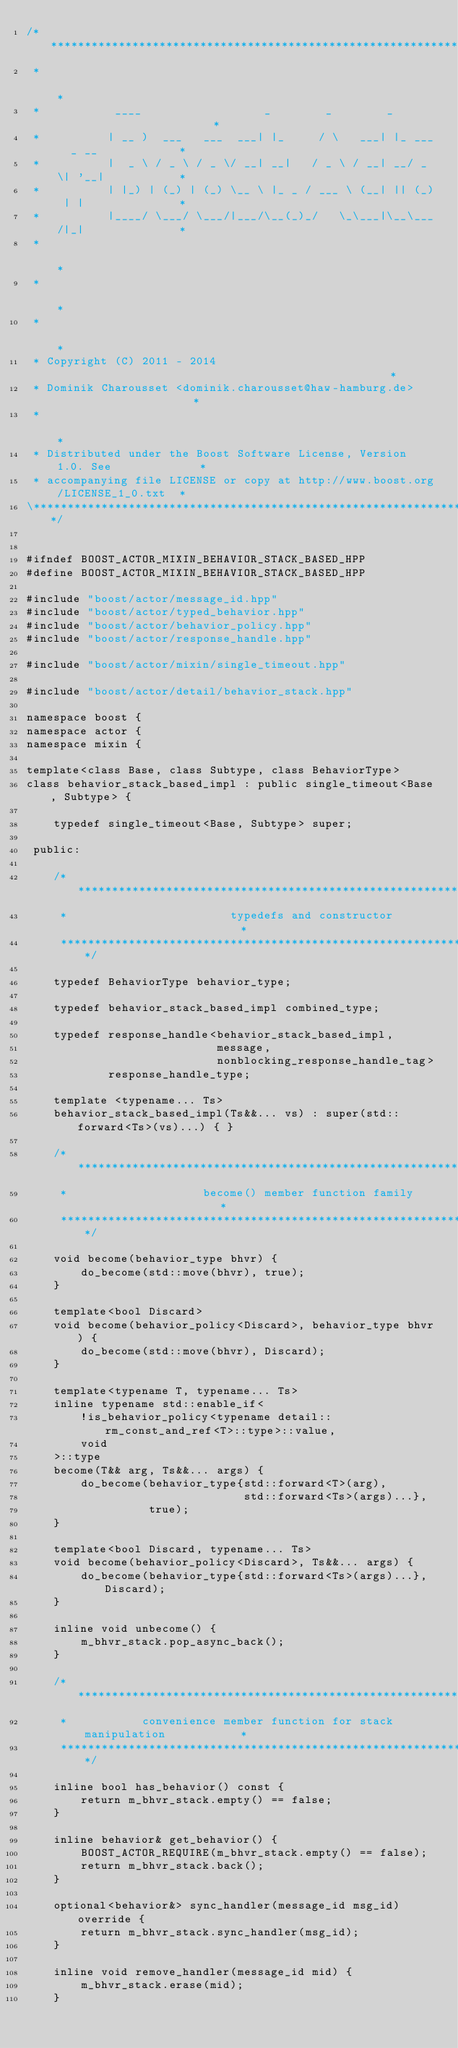Convert code to text. <code><loc_0><loc_0><loc_500><loc_500><_C++_>/******************************************************************************\
 *                                                                            *
 *           ____                  _        _        _                        *
 *          | __ )  ___   ___  ___| |_     / \   ___| |_ ___  _ __            *
 *          |  _ \ / _ \ / _ \/ __| __|   / _ \ / __| __/ _ \| '__|           *
 *          | |_) | (_) | (_) \__ \ |_ _ / ___ \ (__| || (_) | |              *
 *          |____/ \___/ \___/|___/\__(_)_/   \_\___|\__\___/|_|              *
 *                                                                            *
 *                                                                            *
 *                                                                            *
 * Copyright (C) 2011 - 2014                                                  *
 * Dominik Charousset <dominik.charousset@haw-hamburg.de>                     *
 *                                                                            *
 * Distributed under the Boost Software License, Version 1.0. See             *
 * accompanying file LICENSE or copy at http://www.boost.org/LICENSE_1_0.txt  *
\******************************************************************************/


#ifndef BOOST_ACTOR_MIXIN_BEHAVIOR_STACK_BASED_HPP
#define BOOST_ACTOR_MIXIN_BEHAVIOR_STACK_BASED_HPP

#include "boost/actor/message_id.hpp"
#include "boost/actor/typed_behavior.hpp"
#include "boost/actor/behavior_policy.hpp"
#include "boost/actor/response_handle.hpp"

#include "boost/actor/mixin/single_timeout.hpp"

#include "boost/actor/detail/behavior_stack.hpp"

namespace boost {
namespace actor {
namespace mixin {

template<class Base, class Subtype, class BehaviorType>
class behavior_stack_based_impl : public single_timeout<Base, Subtype> {

    typedef single_timeout<Base, Subtype> super;

 public:

    /**************************************************************************
     *                        typedefs and constructor                        *
     **************************************************************************/

    typedef BehaviorType behavior_type;

    typedef behavior_stack_based_impl combined_type;

    typedef response_handle<behavior_stack_based_impl,
                            message,
                            nonblocking_response_handle_tag>
            response_handle_type;

    template <typename... Ts>
    behavior_stack_based_impl(Ts&&... vs) : super(std::forward<Ts>(vs)...) { }

    /**************************************************************************
     *                    become() member function family                     *
     **************************************************************************/

    void become(behavior_type bhvr) {
        do_become(std::move(bhvr), true);
    }

    template<bool Discard>
    void become(behavior_policy<Discard>, behavior_type bhvr) {
        do_become(std::move(bhvr), Discard);
    }

    template<typename T, typename... Ts>
    inline typename std::enable_if<
        !is_behavior_policy<typename detail::rm_const_and_ref<T>::type>::value,
        void
    >::type
    become(T&& arg, Ts&&... args) {
        do_become(behavior_type{std::forward<T>(arg),
                                std::forward<Ts>(args)...},
                  true);
    }

    template<bool Discard, typename... Ts>
    void become(behavior_policy<Discard>, Ts&&... args) {
        do_become(behavior_type{std::forward<Ts>(args)...}, Discard);
    }

    inline void unbecome() {
        m_bhvr_stack.pop_async_back();
    }

    /**************************************************************************
     *           convenience member function for stack manipulation           *
     **************************************************************************/

    inline bool has_behavior() const {
        return m_bhvr_stack.empty() == false;
    }

    inline behavior& get_behavior() {
        BOOST_ACTOR_REQUIRE(m_bhvr_stack.empty() == false);
        return m_bhvr_stack.back();
    }

    optional<behavior&> sync_handler(message_id msg_id) override {
        return m_bhvr_stack.sync_handler(msg_id);
    }

    inline void remove_handler(message_id mid) {
        m_bhvr_stack.erase(mid);
    }
</code> 